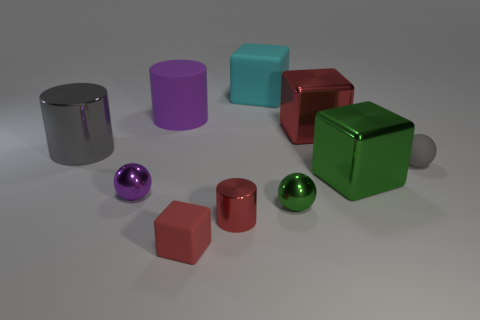Are there fewer big rubber objects behind the big cyan matte cube than gray metal things?
Ensure brevity in your answer.  Yes. The tiny gray object that is made of the same material as the large cyan thing is what shape?
Make the answer very short. Sphere. What number of shiny things are tiny gray balls or small green cylinders?
Your answer should be very brief. 0. Are there the same number of tiny matte things that are behind the small gray rubber object and yellow matte cylinders?
Offer a very short reply. Yes. There is a metallic cube that is behind the big gray cylinder; is it the same color as the small metallic cylinder?
Your answer should be compact. Yes. There is a large object that is both behind the large red shiny cube and to the left of the small red cylinder; what is its material?
Offer a very short reply. Rubber. Are there any shiny objects to the left of the tiny sphere on the left side of the small green metal object?
Your answer should be very brief. Yes. Is the material of the green sphere the same as the big gray object?
Give a very brief answer. Yes. The tiny thing that is in front of the tiny gray matte sphere and to the right of the small cylinder has what shape?
Your answer should be compact. Sphere. What size is the gray object that is left of the shiny sphere that is on the right side of the small red shiny cylinder?
Keep it short and to the point. Large. 